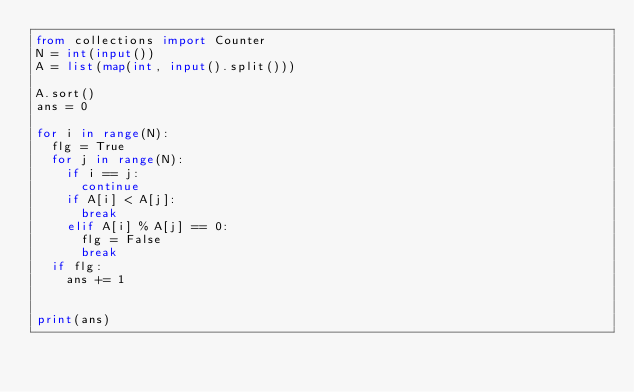<code> <loc_0><loc_0><loc_500><loc_500><_Python_>from collections import Counter
N = int(input())
A = list(map(int, input().split()))

A.sort()
ans = 0

for i in range(N):
  flg = True
  for j in range(N):
    if i == j:
      continue
    if A[i] < A[j]:
      break
    elif A[i] % A[j] == 0:
      flg = False
      break
  if flg:
    ans += 1
      

print(ans)</code> 